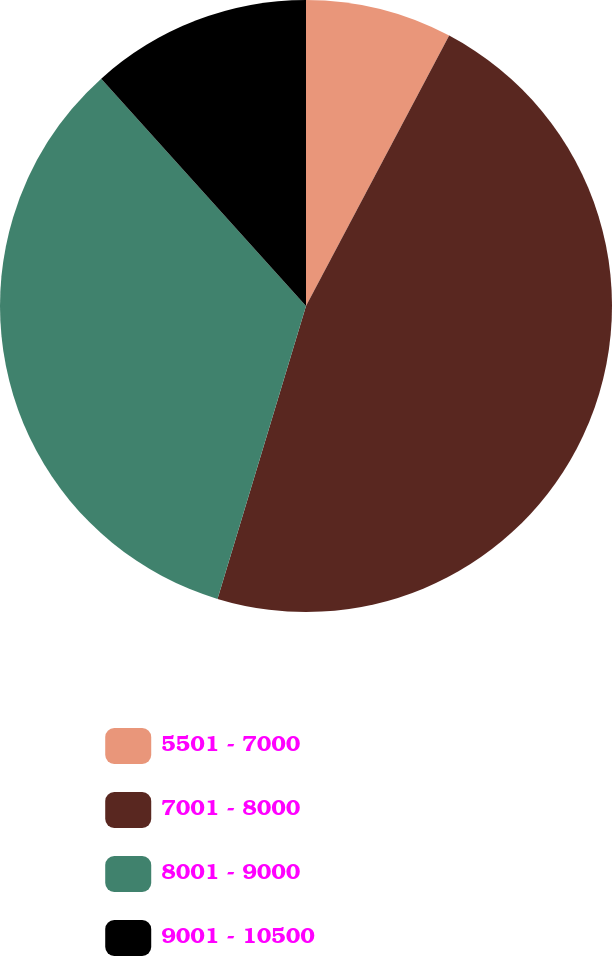Convert chart to OTSL. <chart><loc_0><loc_0><loc_500><loc_500><pie_chart><fcel>5501 - 7000<fcel>7001 - 8000<fcel>8001 - 9000<fcel>9001 - 10500<nl><fcel>7.75%<fcel>46.92%<fcel>33.66%<fcel>11.67%<nl></chart> 